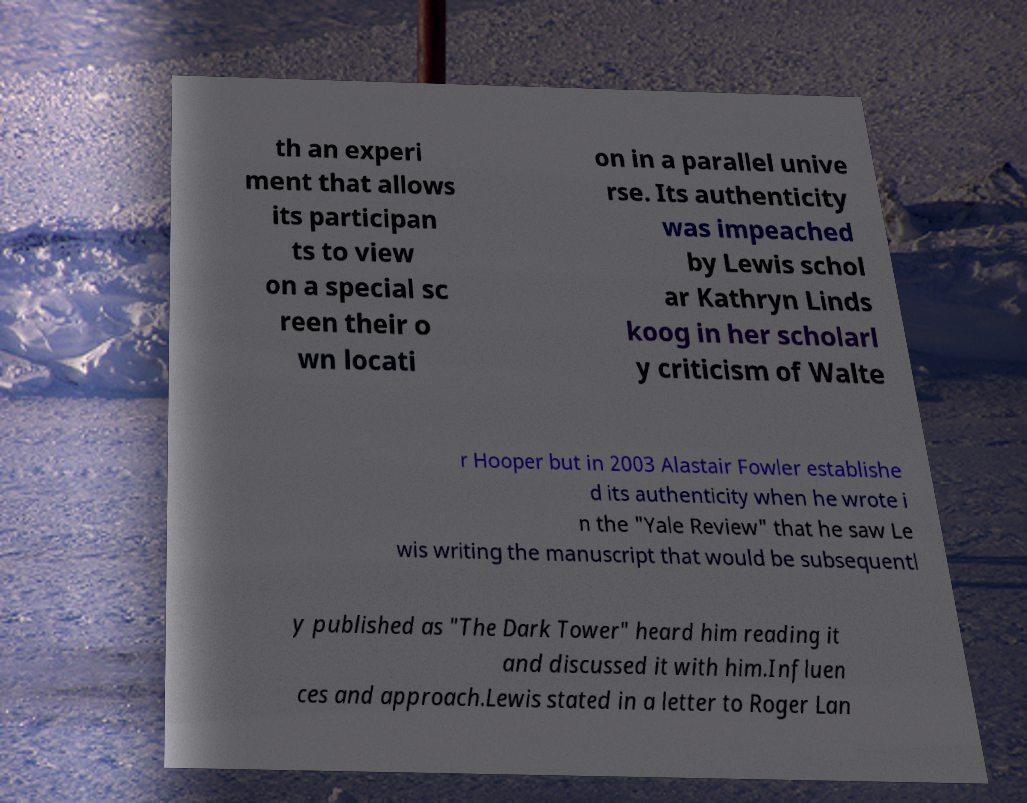Can you accurately transcribe the text from the provided image for me? th an experi ment that allows its participan ts to view on a special sc reen their o wn locati on in a parallel unive rse. Its authenticity was impeached by Lewis schol ar Kathryn Linds koog in her scholarl y criticism of Walte r Hooper but in 2003 Alastair Fowler establishe d its authenticity when he wrote i n the "Yale Review" that he saw Le wis writing the manuscript that would be subsequentl y published as "The Dark Tower" heard him reading it and discussed it with him.Influen ces and approach.Lewis stated in a letter to Roger Lan 